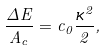Convert formula to latex. <formula><loc_0><loc_0><loc_500><loc_500>\frac { \Delta E } { A _ { c } } = c _ { 0 } \frac { \kappa ^ { 2 } } { 2 } ,</formula> 